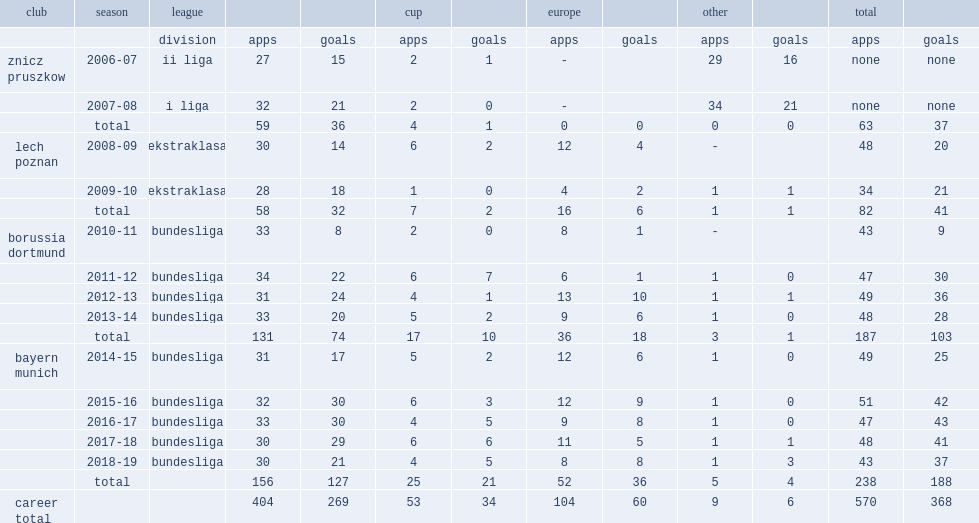Which club did robert lewandowski play for in 2009-10? Lech poznan. 